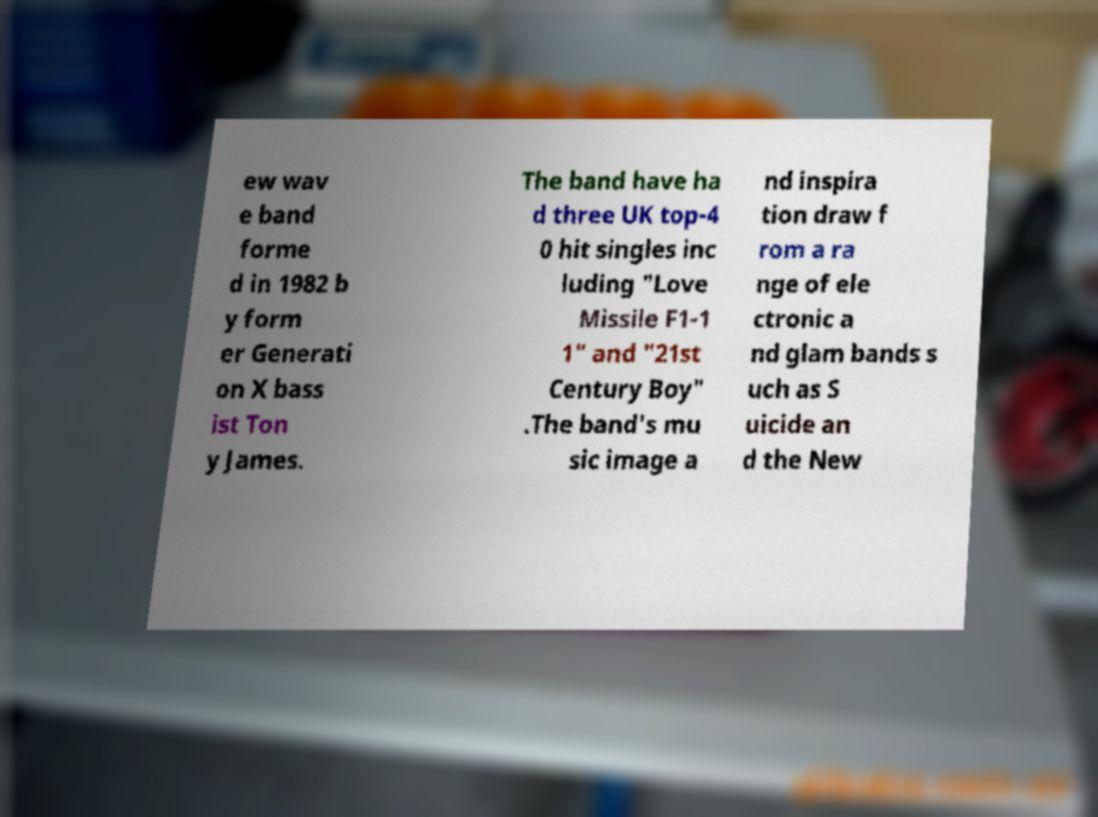Can you accurately transcribe the text from the provided image for me? ew wav e band forme d in 1982 b y form er Generati on X bass ist Ton y James. The band have ha d three UK top-4 0 hit singles inc luding "Love Missile F1-1 1" and "21st Century Boy" .The band's mu sic image a nd inspira tion draw f rom a ra nge of ele ctronic a nd glam bands s uch as S uicide an d the New 